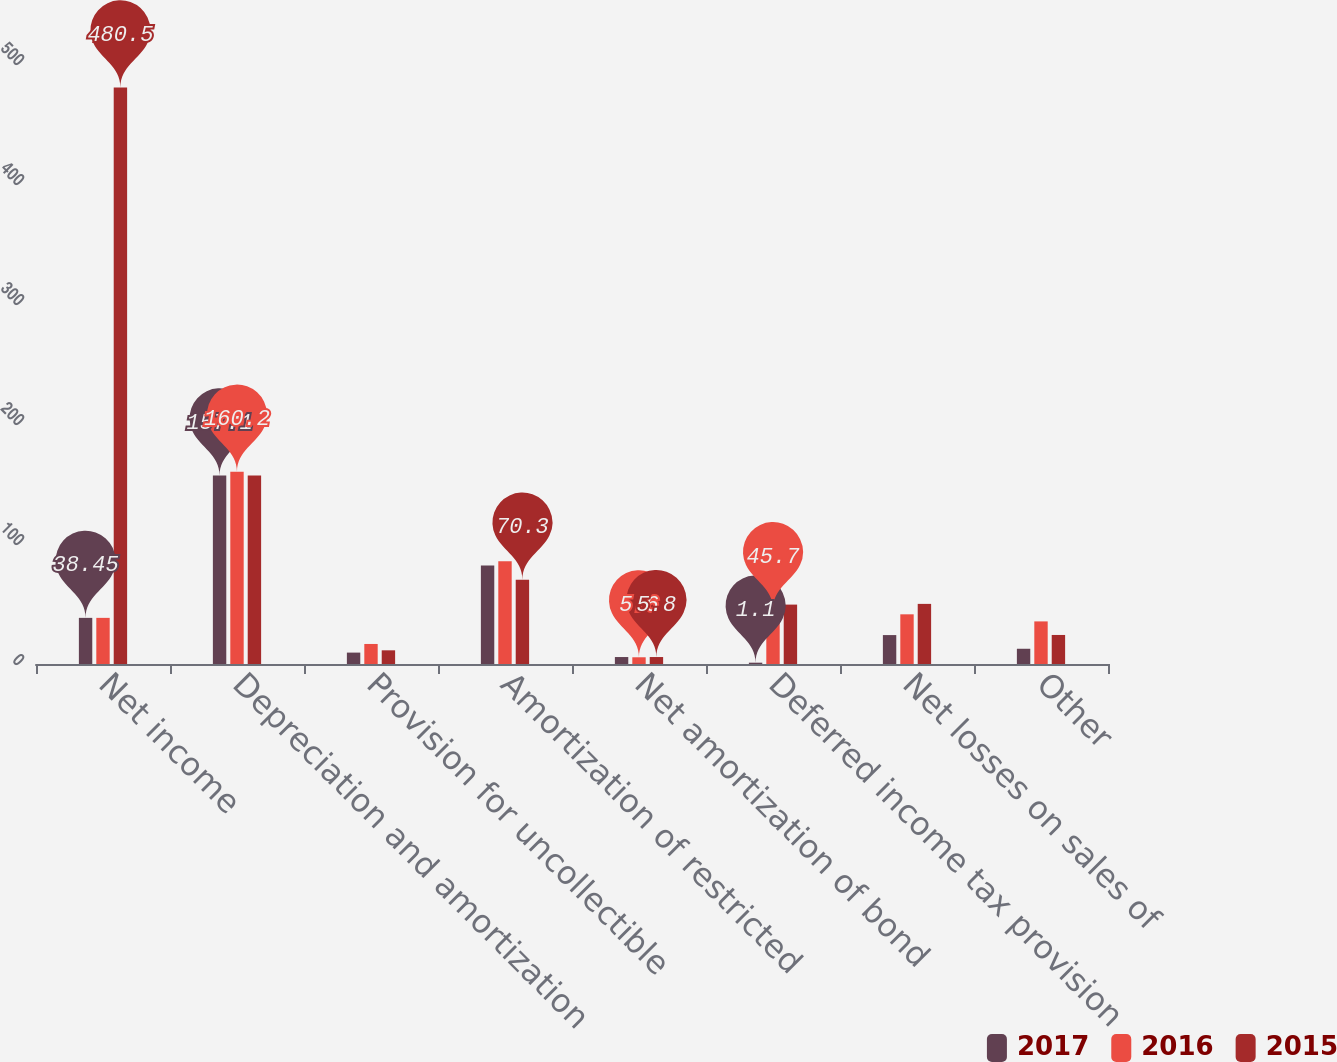<chart> <loc_0><loc_0><loc_500><loc_500><stacked_bar_chart><ecel><fcel>Net income<fcel>Depreciation and amortization<fcel>Provision for uncollectible<fcel>Amortization of restricted<fcel>Net amortization of bond<fcel>Deferred income tax provision<fcel>Net losses on sales of<fcel>Other<nl><fcel>2017<fcel>38.45<fcel>157.1<fcel>9.5<fcel>82<fcel>5.8<fcel>1.1<fcel>24.1<fcel>12.7<nl><fcel>2016<fcel>38.45<fcel>160.2<fcel>16.7<fcel>85.6<fcel>5.6<fcel>45.7<fcel>41.4<fcel>35.5<nl><fcel>2015<fcel>480.5<fcel>157<fcel>11.4<fcel>70.3<fcel>5.8<fcel>49.5<fcel>50.1<fcel>24.2<nl></chart> 